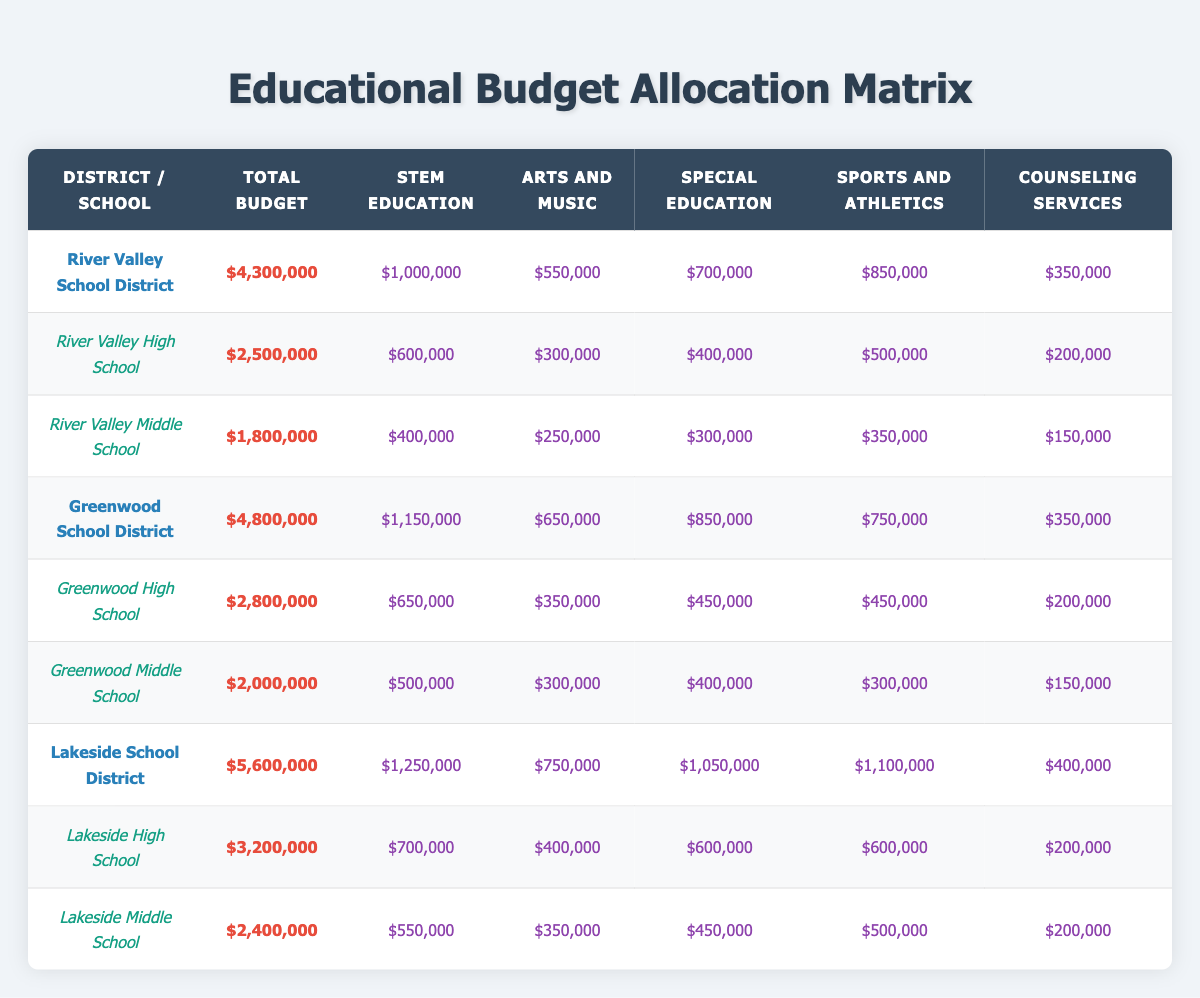What is the total budget for Lakeside School District? The total budget for Lakeside School District is listed in the table under the district's row. It states the total budget is $5,600,000.
Answer: $5,600,000 How much is allocated to STEM Education in River Valley High School? The budget allocation for River Valley High School lists STEM Education directly, which is $600,000.
Answer: $600,000 Is the budget for Arts and Music higher in Greenwood High School than in Lakeside High School? In the table, Greenwood High School has an allocation of $350,000 for Arts and Music, while Lakeside High School has $400,000. Since $350,000 is less than $400,000, the answer is no.
Answer: No What is the total budget allocation for Special Education across all schools in the River Valley School District? The table shows that River Valley High School allocates $400,000 for Special Education and River Valley Middle School allocates $300,000. Summing these gives $400,000 + $300,000 = $700,000.
Answer: $700,000 Which school has the highest budget allocation for Sports and Athletics? Examining the Sports and Athletics budgets in the table, Lakeside High School has an allocation of $600,000, which is higher than that of any other school.
Answer: Lakeside High School What is the average budget allocation for Counseling Services across all schools? The Counseling Services allocations are $200,000 (River Valley High School), $150,000 (River Valley Middle School), $200,000 (Greenwood High School), $150,000 (Greenwood Middle School), $200,000 (Lakeside High School), and $200,000 (Lakeside Middle School). The total is $1,050,000. There are 6 schools, so the average is $1,050,000 / 6 = $175,000.
Answer: $175,000 Does any school in Greenwood School District allocate more than $500,000 to Sports and Athletics? Reviewing the table, Greenwood High School allocates $450,000 and Greenwood Middle School allocates $300,000 for Sports and Athletics. Neither exceeds $500,000, so the answer is no.
Answer: No How much more is allocated to Special Education in Lakeside High School compared to Greenwood Middle School? Lakeside High School allocates $600,000 to Special Education while Greenwood Middle School allocates $400,000. The difference is $600,000 - $400,000 = $200,000.
Answer: $200,000 